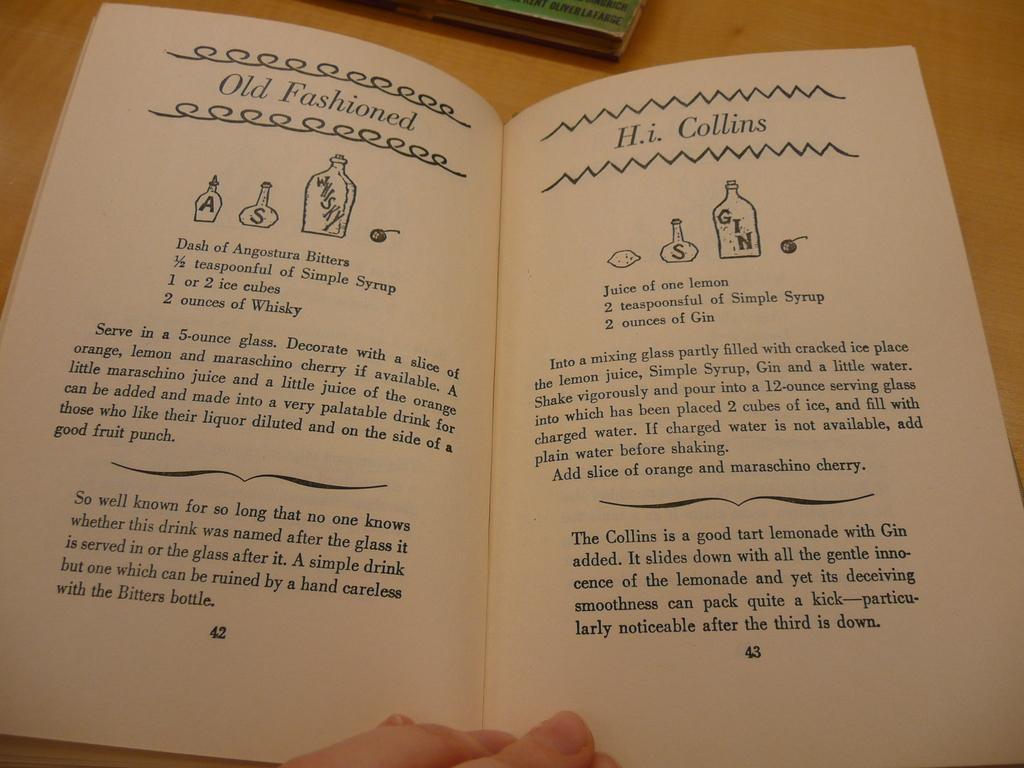<image>
Create a compact narrative representing the image presented. A book opened to page 42 and 43 where the title is Old Fashioned. 